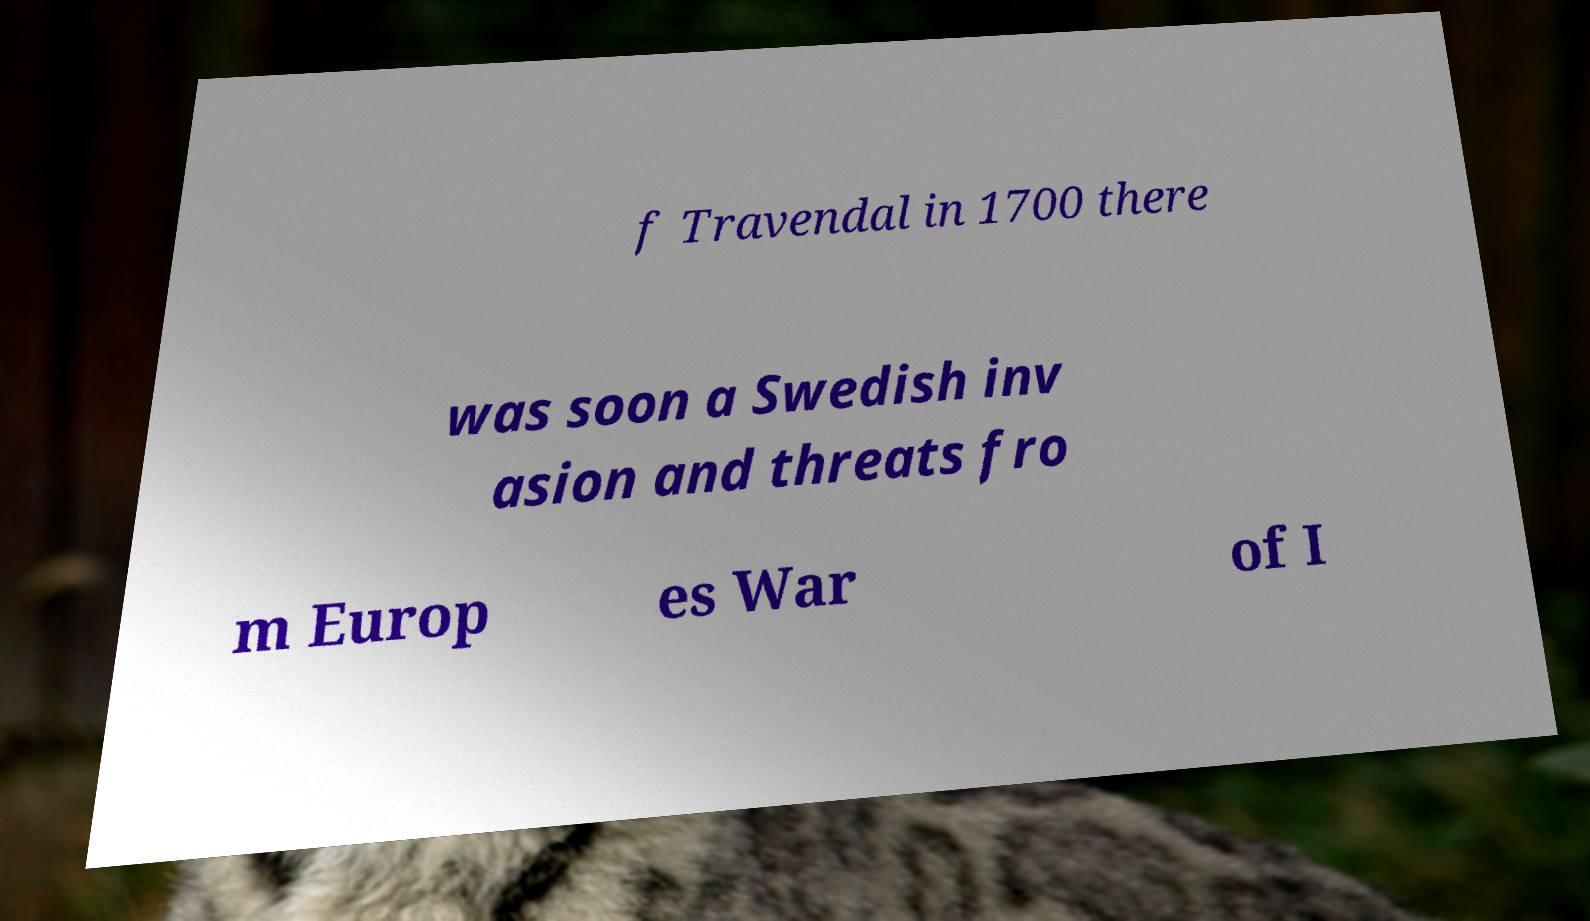I need the written content from this picture converted into text. Can you do that? f Travendal in 1700 there was soon a Swedish inv asion and threats fro m Europ es War of I 